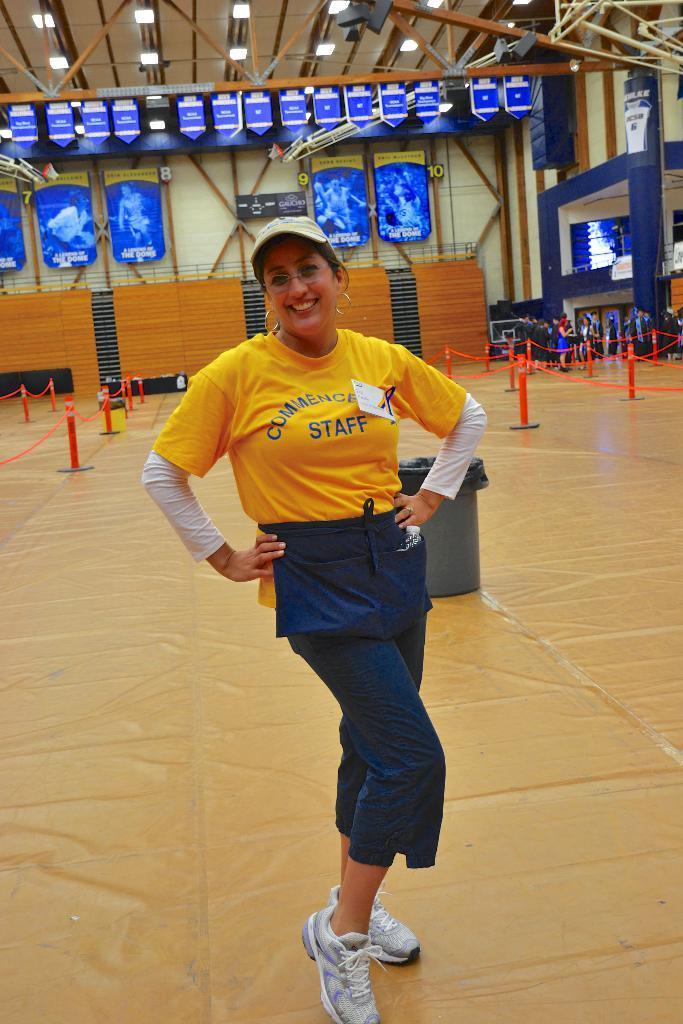Describe this image in one or two sentences. In the center of the image we can see a lady is standing and smiling and wearing a cap. In the background of the image we can see the barricades, wall, boards, pillars, screen and a group of people are standing. At the top of the image we can see the rods, roof and lights. At the bottom of the image we can see the floor. In the middle of the image we can see a bin. 